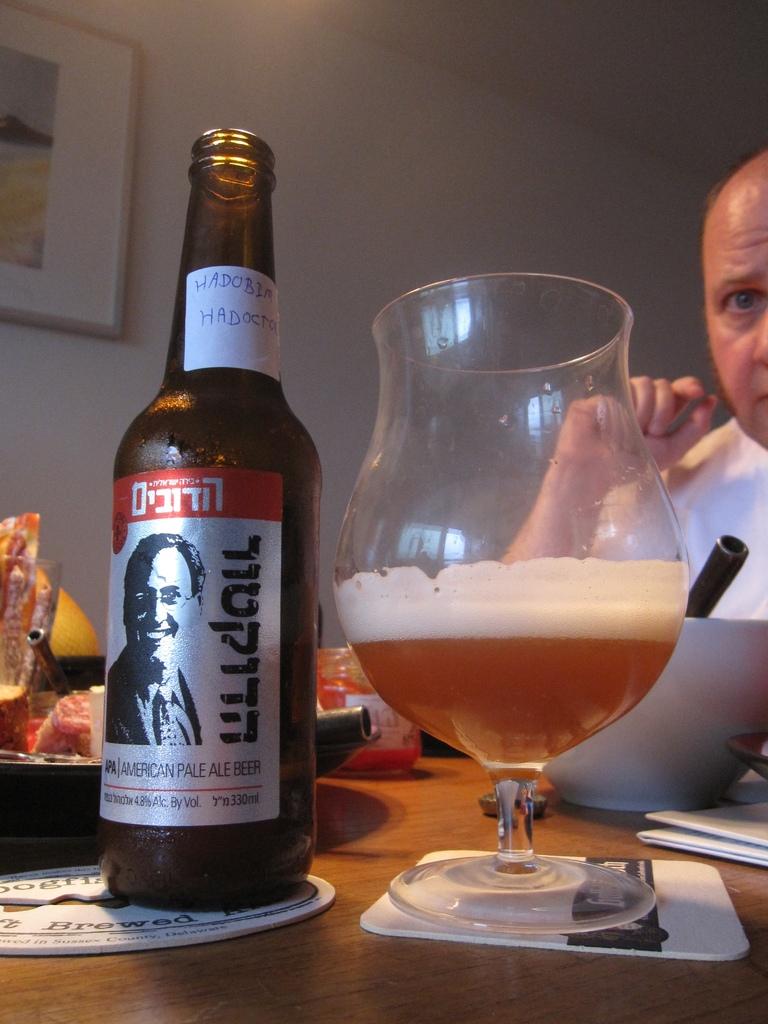Is this an american pale ale?
Ensure brevity in your answer.  Yes. 